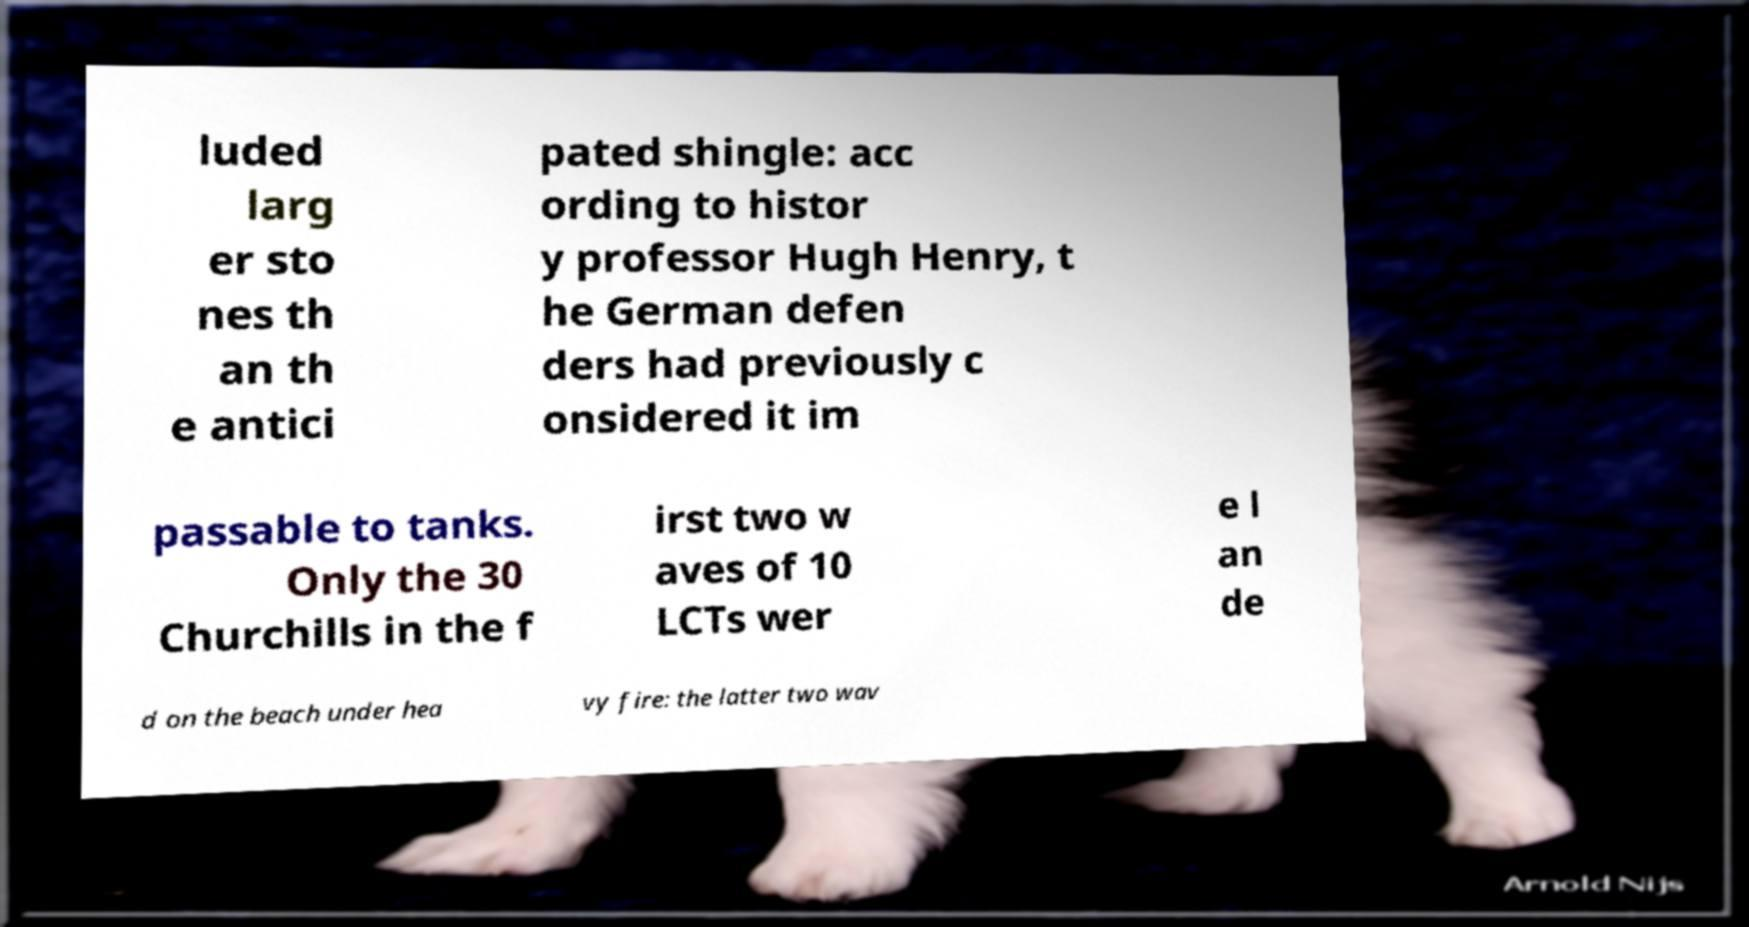Can you read and provide the text displayed in the image?This photo seems to have some interesting text. Can you extract and type it out for me? luded larg er sto nes th an th e antici pated shingle: acc ording to histor y professor Hugh Henry, t he German defen ders had previously c onsidered it im passable to tanks. Only the 30 Churchills in the f irst two w aves of 10 LCTs wer e l an de d on the beach under hea vy fire: the latter two wav 